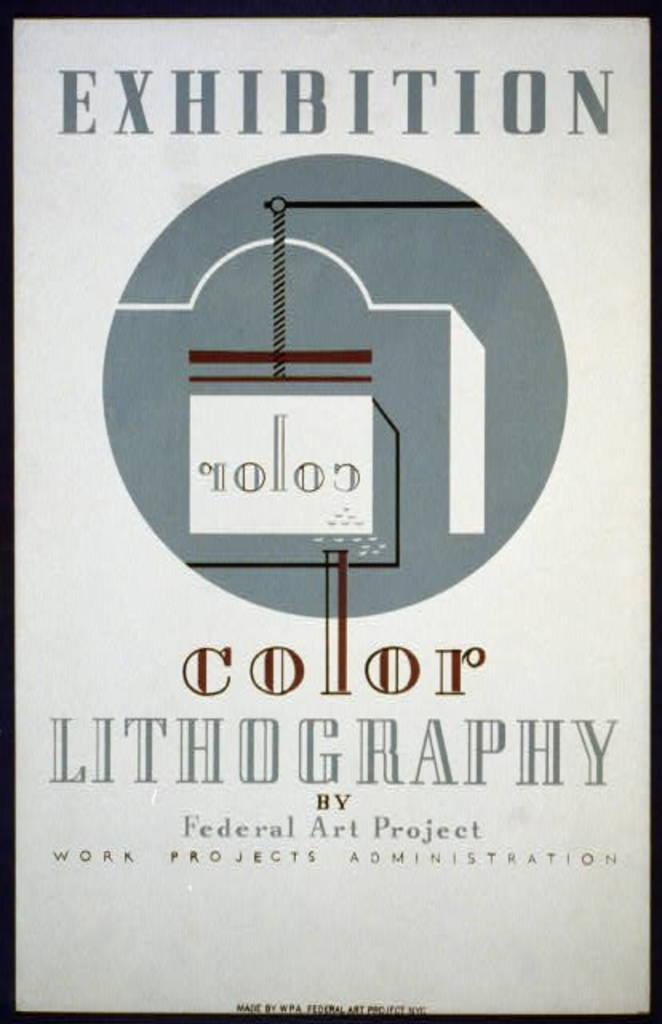<image>
Create a compact narrative representing the image presented. A poster shows an exhibition is about Lithography. 